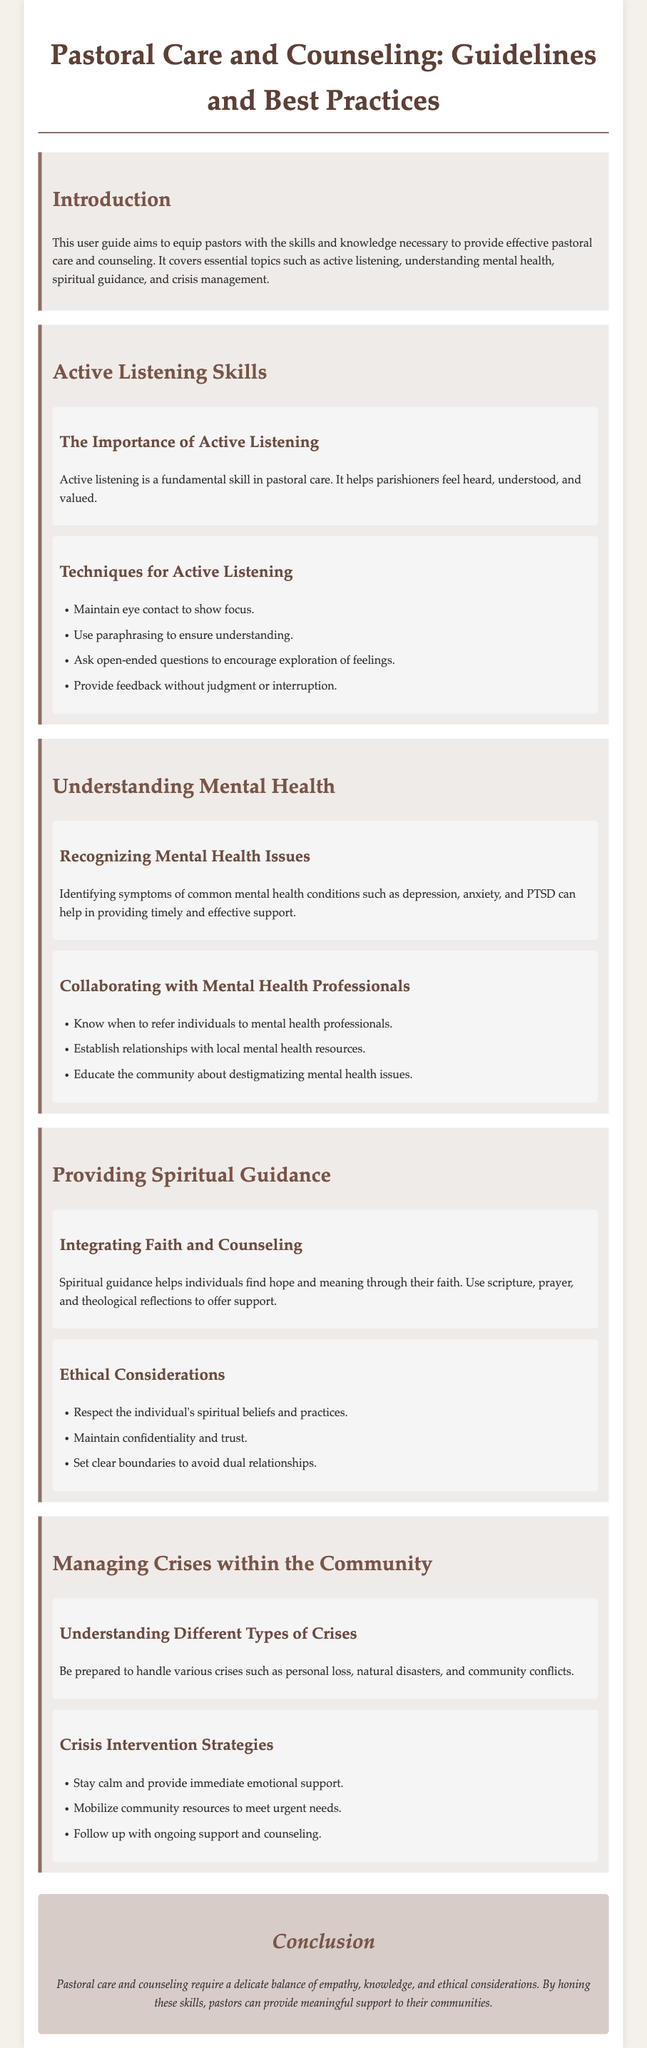what is the title of the user guide? The title is explicitly stated at the beginning of the document.
Answer: Pastoral Care and Counseling: Guidelines and Best Practices how many chapters are there in the document? The chapters are outlined in the document, and you can count them.
Answer: Four what is a key technique for active listening? The document provides multiple techniques for active listening, highlighting one in particular.
Answer: Maintain eye contact which mental health issues are mentioned as common conditions? The document lists specific mental health conditions that pastors should be aware of.
Answer: Depression, anxiety, PTSD what is one ethical consideration in providing spiritual guidance? The document emphasizes the importance of ethics when providing spiritual guidance, specifying a key consideration.
Answer: Respect the individual's spiritual beliefs and practices what should pastors do in case of a natural disaster? The document outlines the type of crises to prepare for, including specific actions.
Answer: Be prepared to handle various crises what is one crisis intervention strategy mentioned? The document provides strategies for crisis intervention, highlighting one method.
Answer: Stay calm and provide immediate emotional support how does spiritual guidance help individuals, according to the document? The document describes the benefits of providing spiritual guidance to individuals.
Answer: Find hope and meaning through their faith 